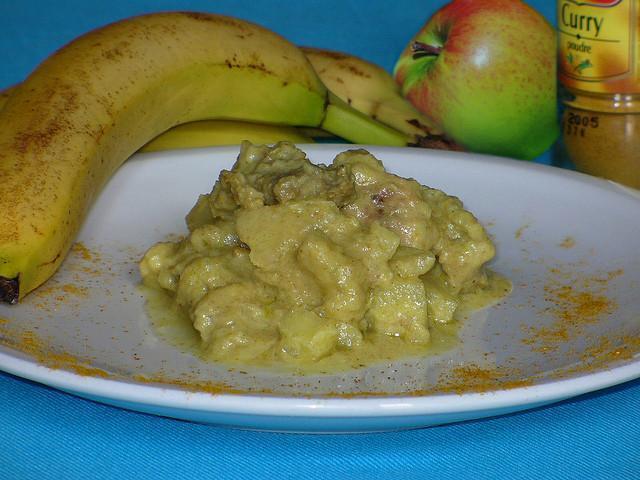Does the image validate the caption "The apple is at the right side of the banana."?
Answer yes or no. Yes. 